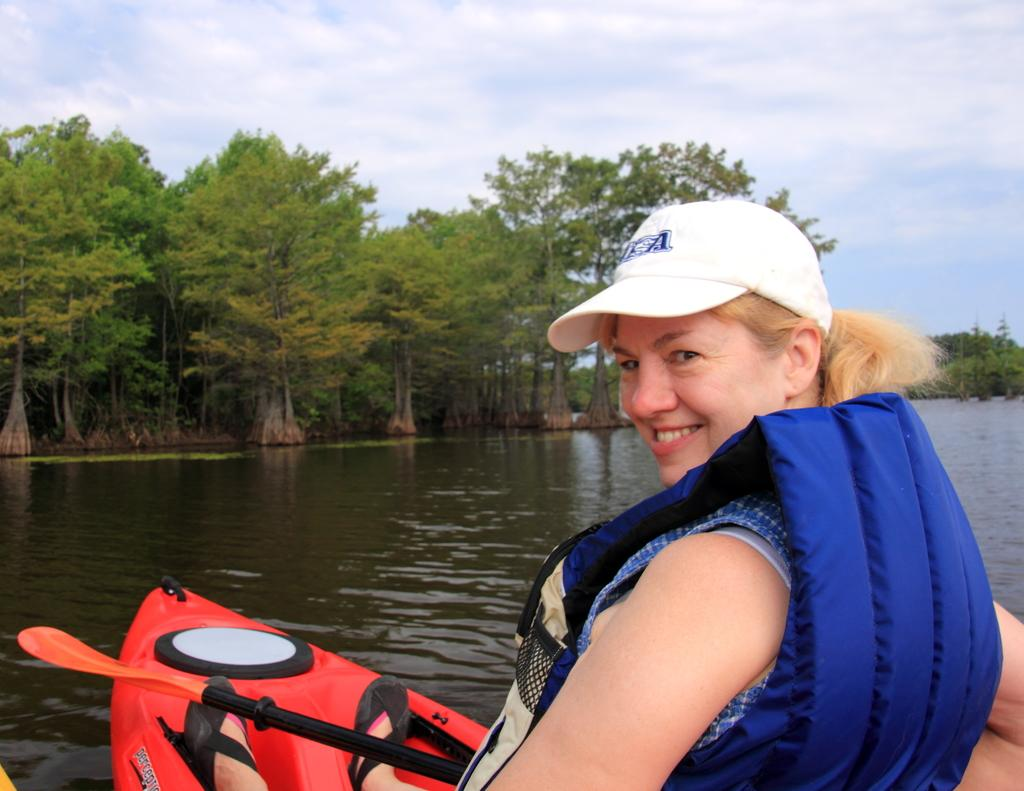What is the woman in the image doing? The woman is in a boat in the image. What safety precaution is the woman taking in the image? The woman is wearing a life jacket. What is the primary element in the image? There is water in the middle of the image. What can be seen in the background of the image? There are trees in the background of the image. What is visible at the top of the image? The sky is visible at the top of the image. What type of floor can be seen in the image? There is no floor visible in the image, as it is a woman in a boat on water. What is the sun doing in the image? The sun is not mentioned in the image, as it only describes the sky being visible. 